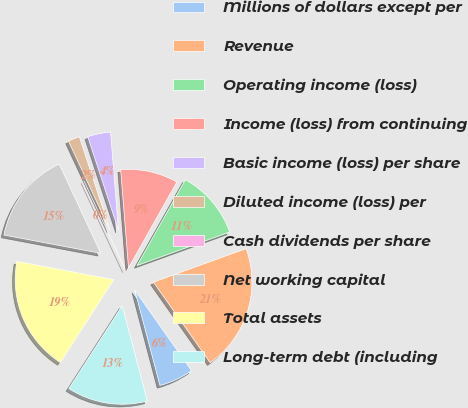<chart> <loc_0><loc_0><loc_500><loc_500><pie_chart><fcel>Millions of dollars except per<fcel>Revenue<fcel>Operating income (loss)<fcel>Income (loss) from continuing<fcel>Basic income (loss) per share<fcel>Diluted income (loss) per<fcel>Cash dividends per share<fcel>Net working capital<fcel>Total assets<fcel>Long-term debt (including<nl><fcel>5.66%<fcel>20.75%<fcel>11.32%<fcel>9.43%<fcel>3.77%<fcel>1.89%<fcel>0.0%<fcel>15.09%<fcel>18.87%<fcel>13.21%<nl></chart> 